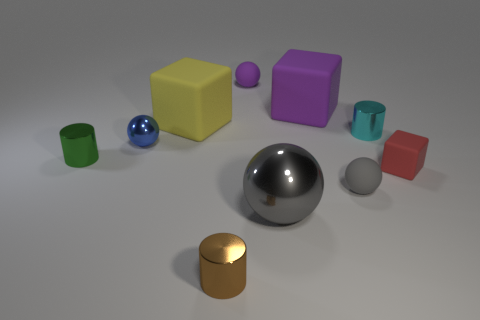What number of cyan shiny cylinders are the same size as the red object?
Your answer should be compact. 1. What is the size of the gray metallic thing?
Offer a very short reply. Large. How many red matte objects are on the left side of the tiny purple rubber thing?
Your answer should be compact. 0. What is the shape of the small purple thing that is the same material as the purple cube?
Offer a terse response. Sphere. Are there fewer large gray balls right of the small gray matte ball than tiny shiny cylinders left of the brown thing?
Your answer should be compact. Yes. Is the number of small metallic balls greater than the number of gray balls?
Your response must be concise. No. What is the material of the small blue sphere?
Provide a succinct answer. Metal. What color is the metal sphere to the right of the big yellow thing?
Offer a very short reply. Gray. Are there more metal objects left of the purple block than cyan things that are to the left of the yellow block?
Your answer should be compact. Yes. There is a purple matte thing that is right of the gray metal sphere that is in front of the metal ball behind the gray rubber thing; what size is it?
Provide a short and direct response. Large. 